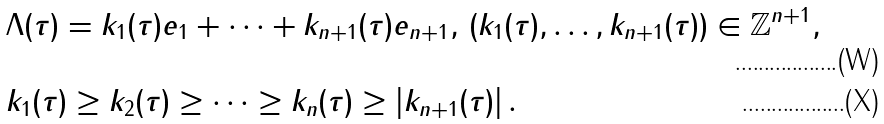Convert formula to latex. <formula><loc_0><loc_0><loc_500><loc_500>& \Lambda ( \tau ) = k _ { 1 } ( \tau ) e _ { 1 } + \dots + k _ { n + 1 } ( \tau ) e _ { n + 1 } , \, ( k _ { 1 } ( \tau ) , \dots , k _ { n + 1 } ( \tau ) ) \in \mathbb { Z } ^ { n + 1 } , \\ & k _ { 1 } ( \tau ) \geq k _ { 2 } ( \tau ) \geq \dots \geq k _ { n } ( \tau ) \geq \left | k _ { n + 1 } ( \tau ) \right | .</formula> 